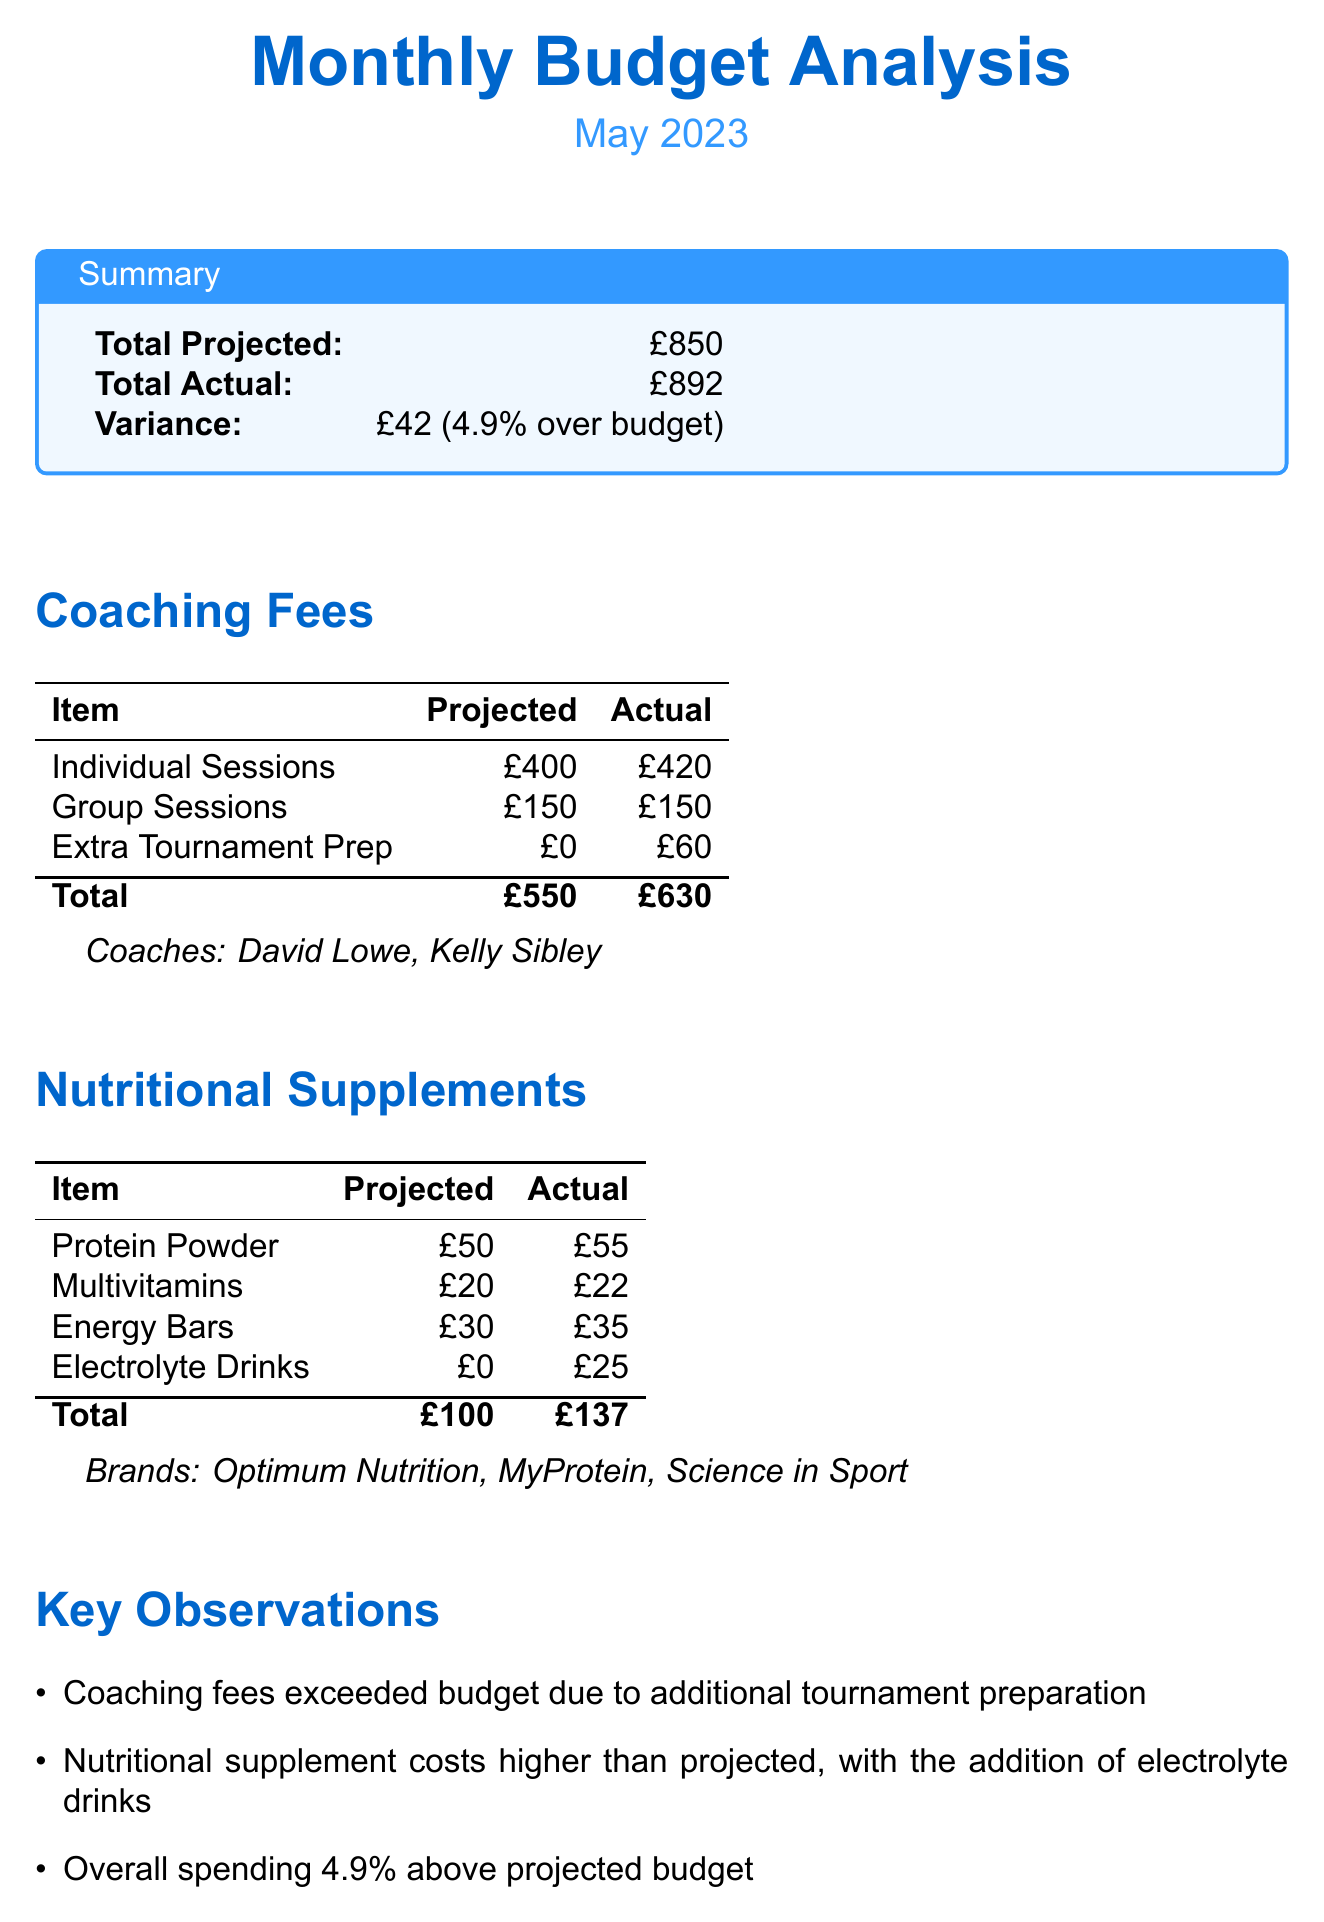What was the total projected budget for May 2023? The total projected budget is stated in the summary section, which indicates £850.
Answer: £850 What were the actual coaching fees for individual sessions? The actual coaching fees for individual sessions are listed under the coaching fees section, which shows £420.
Answer: £420 What is the variance between projected and actual spending? The variance is calculated as the difference between total projected and actual spending, which is £42.
Answer: £42 Which supplements exceeded their projected costs? The supplements that exceeded their projected costs are noted in the nutritional supplements section, including protein powder and electrolyte drinks.
Answer: Protein powder, electrolyte drinks What percentage was the overall spending above the projected budget? The overall spending percentage above the projected budget is specified in the key observations section as 4.9%.
Answer: 4.9% Who are the coaches listed in the document? The document provides a list of coaches under the coaching fees section, which includes David Lowe and Kelly Sibley.
Answer: David Lowe, Kelly Sibley Which adjustment is suggested for future budgets? The upcoming adjustments section suggests considering a small buffer for unexpected expenses in future budgets.
Answer: Small buffer for unexpected expenses How much was spent on electrolyte drinks? The actual spending on electrolyte drinks is provided in the nutritional supplements section, showing £25.
Answer: £25 